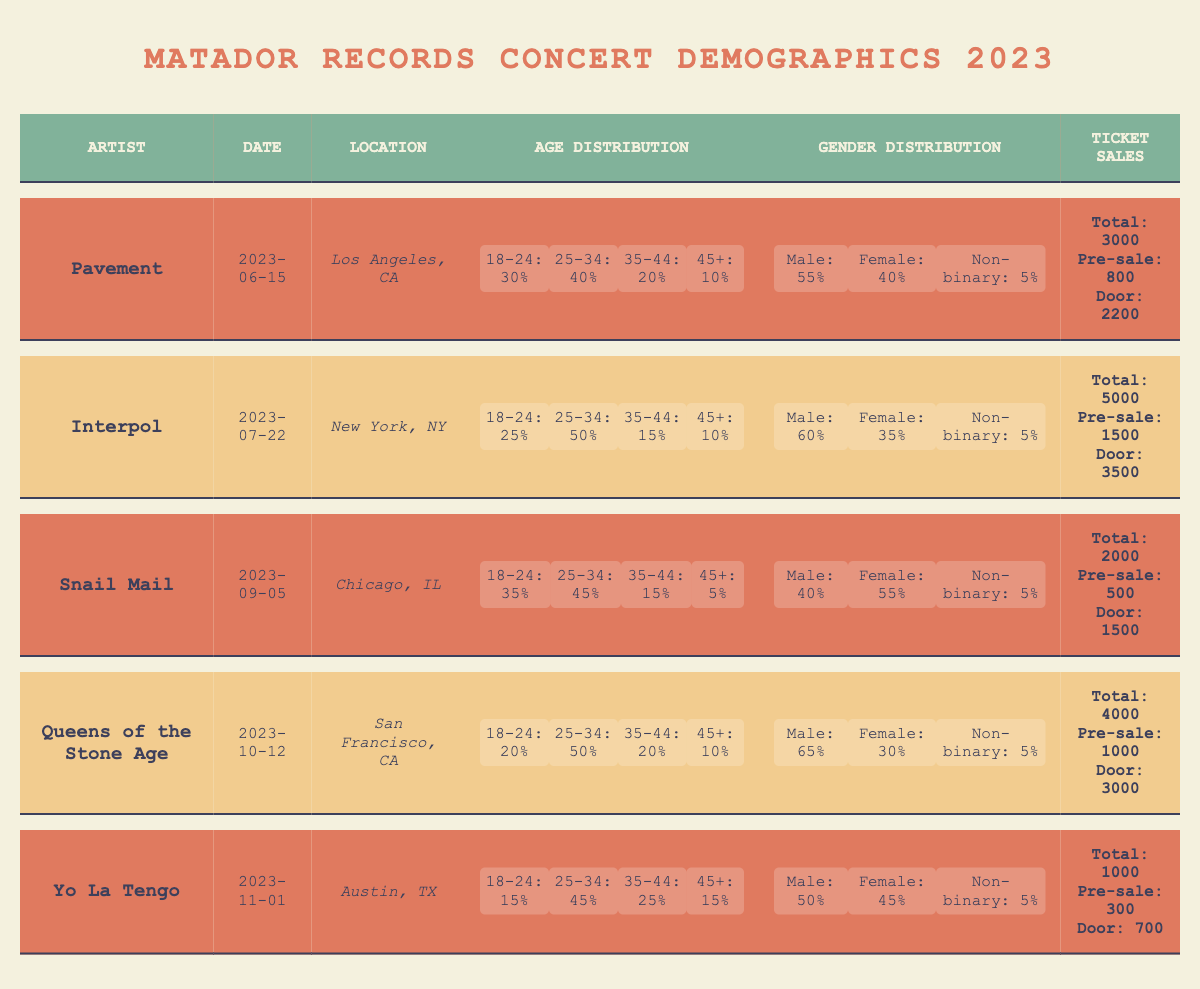What is the total ticket sales for the concert by Pavement? The table shows that the total ticket sales for Pavement's concert on June 15, 2023, is listed under ticket sales. The value is 3000.
Answer: 3000 What percentage of attendees for Interpol's concert were aged 25-34? The age distribution for Interpol's concert indicates that 50% of the attendees were aged 25-34.
Answer: 50% How many more males attended the Yo La Tengo concert compared to females? The male percentage for Yo La Tengo's concert is 50%, and the female percentage is 45%. The difference is 50 - 45 = 5.
Answer: 5 What is the average percentage of attendees in the age group 18-24 across all concerts? Adding the percentages for the 18-24 age group: 30 (Pavement) + 25 (Interpol) + 35 (Snail Mail) + 20 (Queens of the Stone Age) + 15 (Yo La Tengo) = 125. There are 5 concerts, so the average is 125/5 = 25.
Answer: 25 Did Snail Mail have more females than males at their concert? The gender distribution shows that Snail Mail had 55% female and 40% male attendees. Since 55 is greater than 40, the answer is yes.
Answer: Yes What is the total percentage of attendees aged 35-44 across all concerts? The percentages for the 35-44 age group are: 20 (Pavement) + 15 (Interpol) + 15 (Snail Mail) + 20 (Queens of the Stone Age) + 25 (Yo La Tengo) = 95.
Answer: 95 Which concert had the highest number of total ticket sales? Comparing the total ticket sales: Pavement (3000), Interpol (5000), Snail Mail (2000), Queens of the Stone Age (4000), Yo La Tengo (1000). The highest is Interpol with 5000.
Answer: Interpol What gender had the least proportion of attendees at the concert for Queens of the Stone Age? The gender distribution shows males at 65%, females at 30%, and non-binary at 5%. Here, non-binary has the least proportion of attendees.
Answer: Non-binary What is the percentage of door sales for the concert by Snail Mail? The ticket sales for Snail Mail show total sales of 2000 and door sales of 1500. The percentage is (1500/2000) * 100 = 75%.
Answer: 75% How many total attendees were there at the concerts held in California? The concerts in California were by Pavement (3000 attendees) and Queens of the Stone Age (4000 attendees). The total is 3000 + 4000 = 7000.
Answer: 7000 